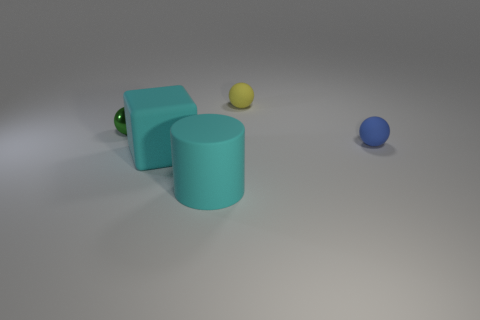Subtract all tiny rubber balls. How many balls are left? 1 Subtract all yellow spheres. How many spheres are left? 2 Add 1 green balls. How many objects exist? 6 Subtract all big cyan blocks. Subtract all cyan rubber objects. How many objects are left? 2 Add 5 small objects. How many small objects are left? 8 Add 2 big blue rubber cubes. How many big blue rubber cubes exist? 2 Subtract 0 gray cubes. How many objects are left? 5 Subtract all blocks. How many objects are left? 4 Subtract 1 spheres. How many spheres are left? 2 Subtract all purple spheres. Subtract all blue cylinders. How many spheres are left? 3 